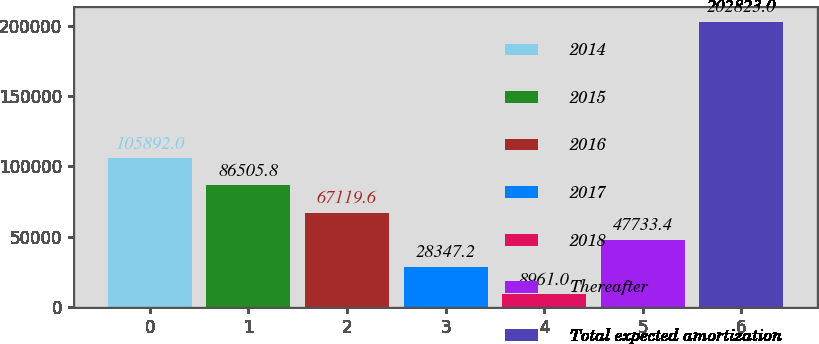<chart> <loc_0><loc_0><loc_500><loc_500><bar_chart><fcel>2014<fcel>2015<fcel>2016<fcel>2017<fcel>2018<fcel>Thereafter<fcel>Total expected amortization<nl><fcel>105892<fcel>86505.8<fcel>67119.6<fcel>28347.2<fcel>8961<fcel>47733.4<fcel>202823<nl></chart> 